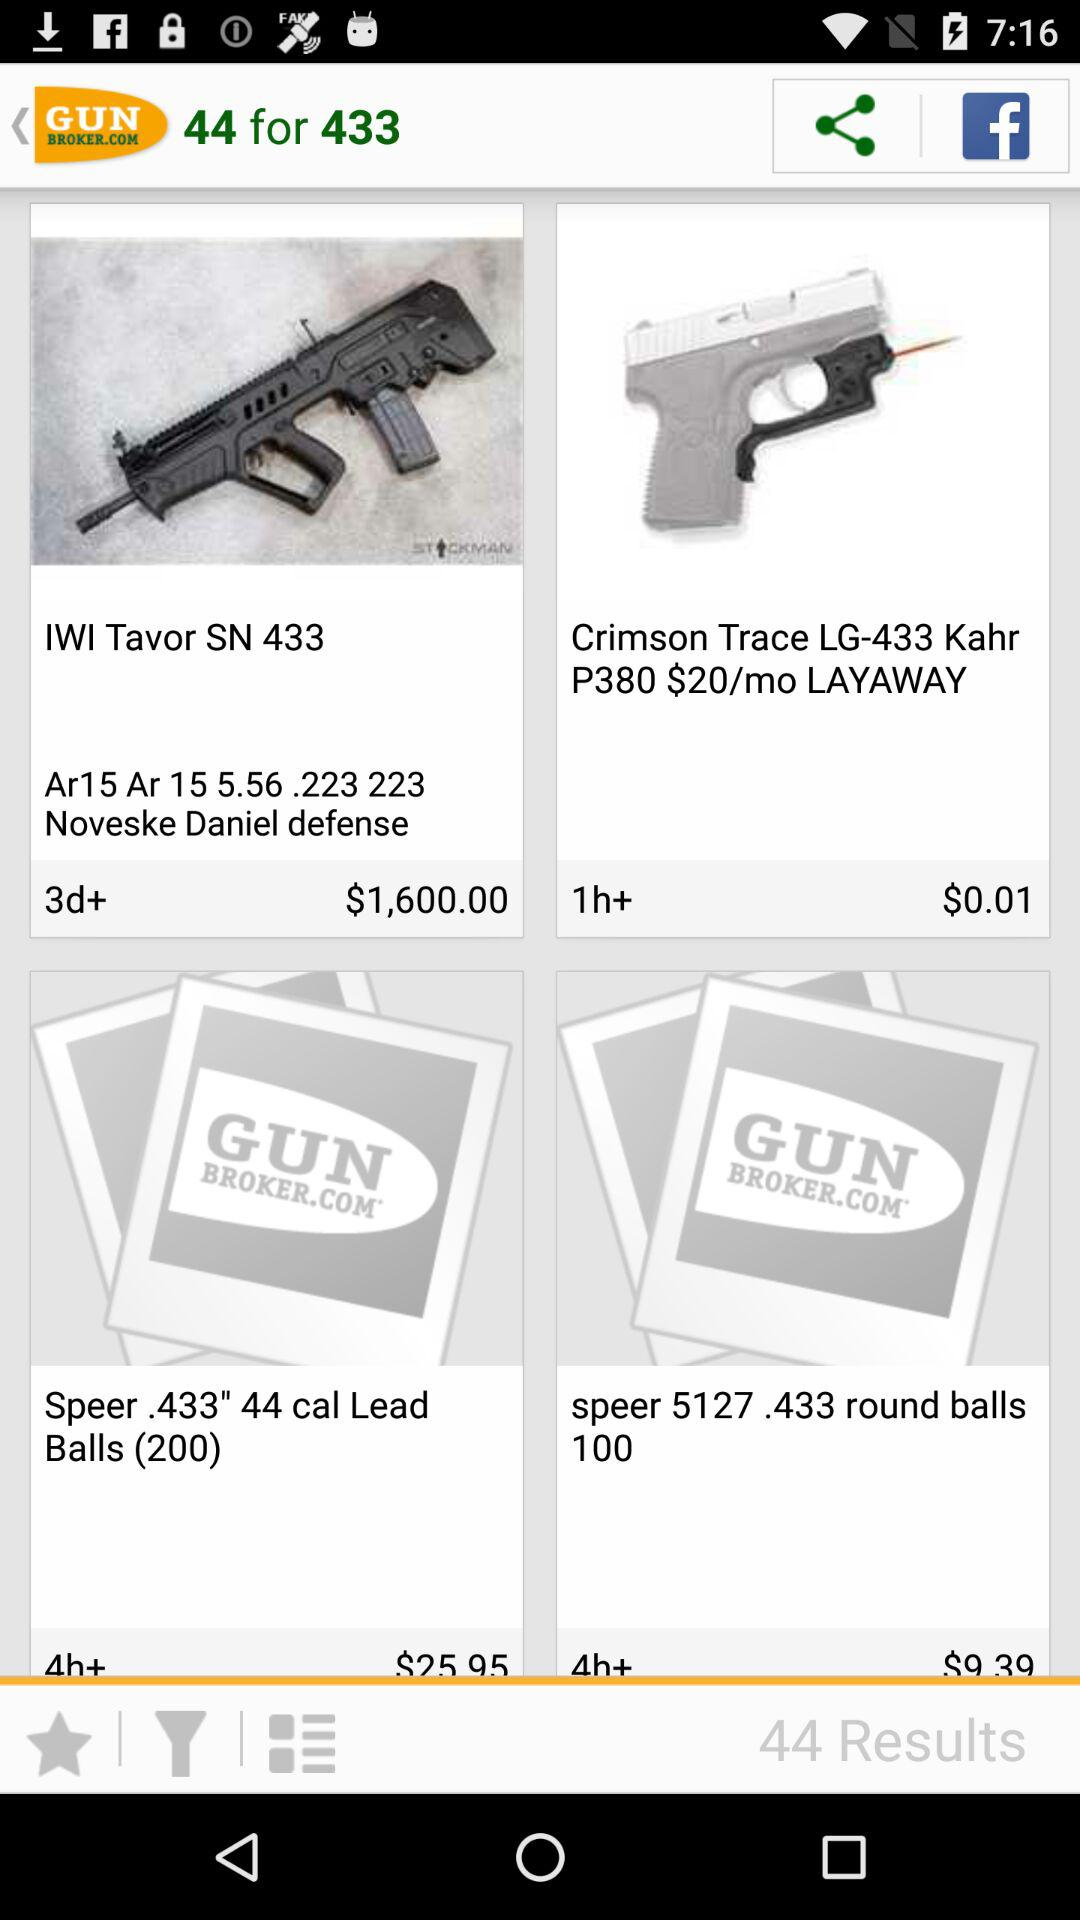Which item has a price of $0.01? The item is "Crimson Trace LG-433". 